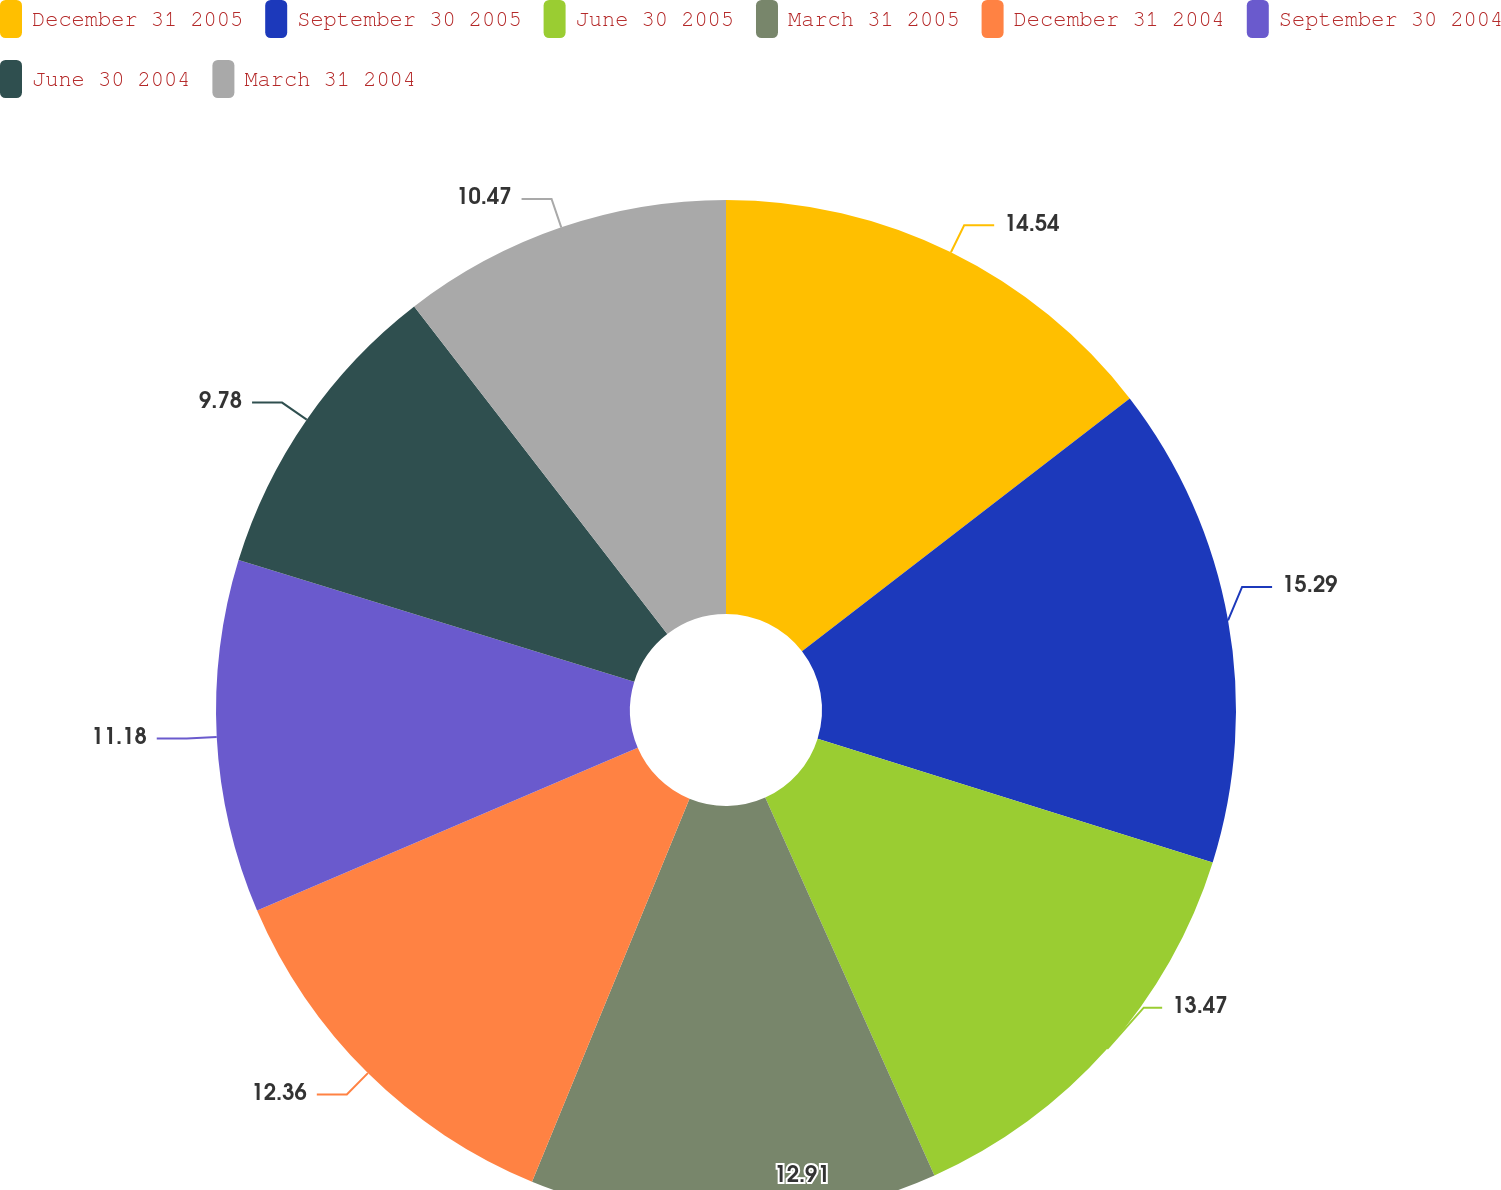<chart> <loc_0><loc_0><loc_500><loc_500><pie_chart><fcel>December 31 2005<fcel>September 30 2005<fcel>June 30 2005<fcel>March 31 2005<fcel>December 31 2004<fcel>September 30 2004<fcel>June 30 2004<fcel>March 31 2004<nl><fcel>14.54%<fcel>15.29%<fcel>13.47%<fcel>12.91%<fcel>12.36%<fcel>11.18%<fcel>9.78%<fcel>10.47%<nl></chart> 